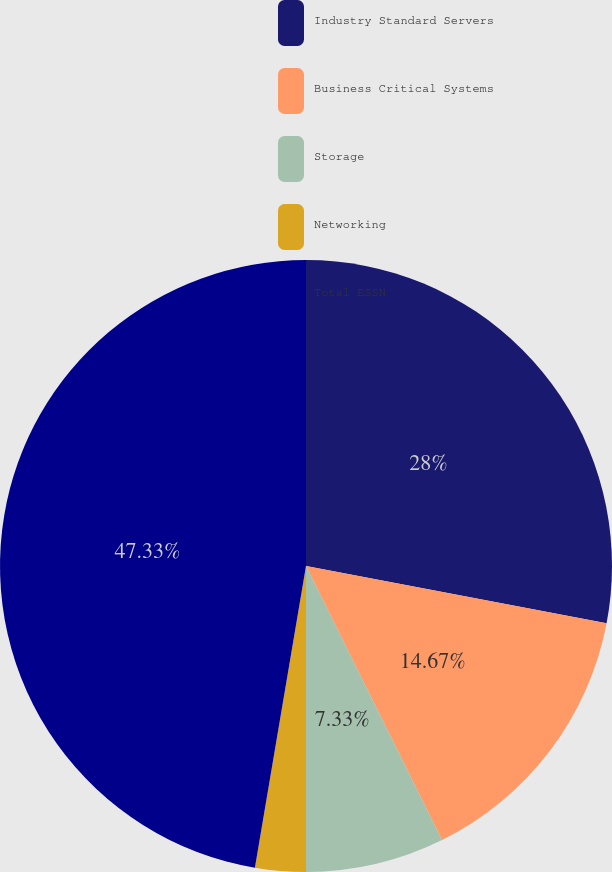Convert chart to OTSL. <chart><loc_0><loc_0><loc_500><loc_500><pie_chart><fcel>Industry Standard Servers<fcel>Business Critical Systems<fcel>Storage<fcel>Networking<fcel>Total ESSN<nl><fcel>28.0%<fcel>14.67%<fcel>7.33%<fcel>2.67%<fcel>47.33%<nl></chart> 